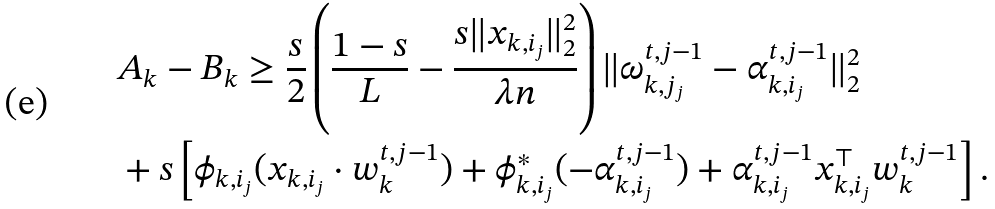<formula> <loc_0><loc_0><loc_500><loc_500>& A _ { k } - B _ { k } \geq \frac { s } { 2 } \left ( \frac { 1 - s } { L } - \frac { s \| x _ { k , i _ { j } } \| _ { 2 } ^ { 2 } } { \lambda n } \right ) \| \omega _ { k , j _ { j } } ^ { t , j - 1 } - \alpha ^ { t , j - 1 } _ { k , i _ { j } } \| _ { 2 } ^ { 2 } \\ & + s \left [ \phi _ { k , i _ { j } } ( x _ { k , i _ { j } } \cdot w _ { k } ^ { t , j - 1 } ) + \phi ^ { * } _ { k , i _ { j } } ( - \alpha ^ { t , j - 1 } _ { k , i _ { j } } ) + \alpha _ { k , i _ { j } } ^ { t , j - 1 } x _ { k , i _ { j } } ^ { \top } w ^ { t , j - 1 } _ { k } \right ] .</formula> 